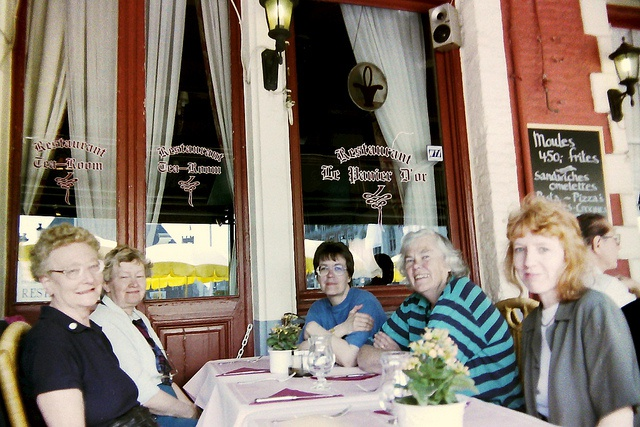Describe the objects in this image and their specific colors. I can see dining table in beige, lightgray, darkgray, and gray tones, people in beige, gray, darkgray, lightgray, and tan tones, people in beige, black, lightgray, and tan tones, people in beige, black, teal, darkgray, and navy tones, and people in beige, lightgray, darkgray, and tan tones in this image. 